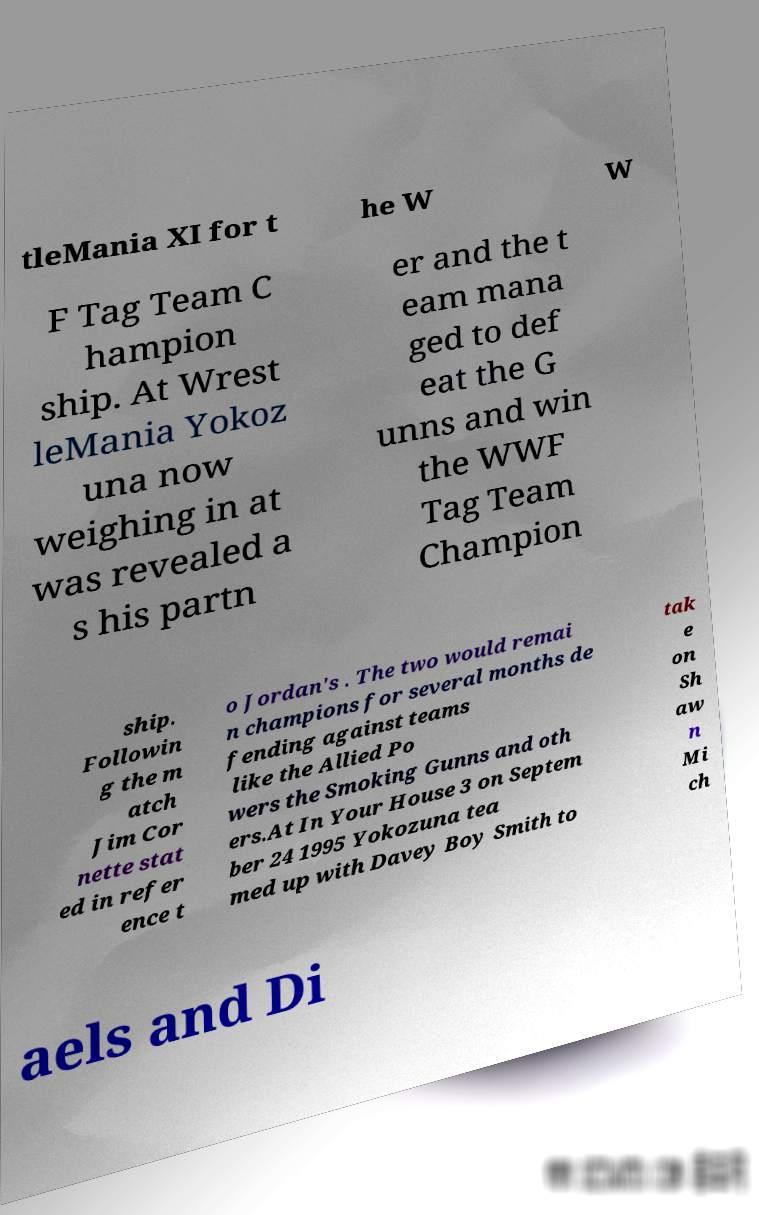Can you accurately transcribe the text from the provided image for me? tleMania XI for t he W W F Tag Team C hampion ship. At Wrest leMania Yokoz una now weighing in at was revealed a s his partn er and the t eam mana ged to def eat the G unns and win the WWF Tag Team Champion ship. Followin g the m atch Jim Cor nette stat ed in refer ence t o Jordan's . The two would remai n champions for several months de fending against teams like the Allied Po wers the Smoking Gunns and oth ers.At In Your House 3 on Septem ber 24 1995 Yokozuna tea med up with Davey Boy Smith to tak e on Sh aw n Mi ch aels and Di 